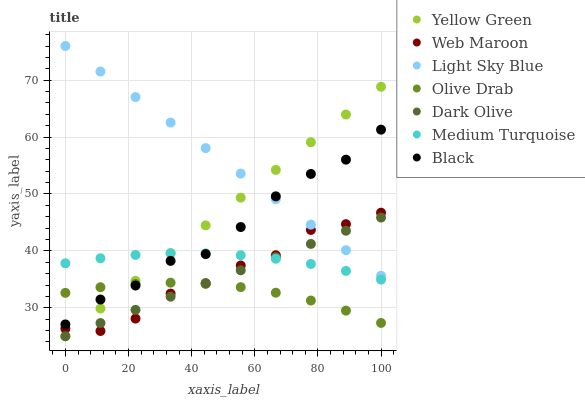Does Olive Drab have the minimum area under the curve?
Answer yes or no. Yes. Does Light Sky Blue have the maximum area under the curve?
Answer yes or no. Yes. Does Dark Olive have the minimum area under the curve?
Answer yes or no. No. Does Dark Olive have the maximum area under the curve?
Answer yes or no. No. Is Dark Olive the smoothest?
Answer yes or no. Yes. Is Web Maroon the roughest?
Answer yes or no. Yes. Is Web Maroon the smoothest?
Answer yes or no. No. Is Dark Olive the roughest?
Answer yes or no. No. Does Yellow Green have the lowest value?
Answer yes or no. Yes. Does Web Maroon have the lowest value?
Answer yes or no. No. Does Light Sky Blue have the highest value?
Answer yes or no. Yes. Does Dark Olive have the highest value?
Answer yes or no. No. Is Dark Olive less than Black?
Answer yes or no. Yes. Is Medium Turquoise greater than Olive Drab?
Answer yes or no. Yes. Does Yellow Green intersect Light Sky Blue?
Answer yes or no. Yes. Is Yellow Green less than Light Sky Blue?
Answer yes or no. No. Is Yellow Green greater than Light Sky Blue?
Answer yes or no. No. Does Dark Olive intersect Black?
Answer yes or no. No. 